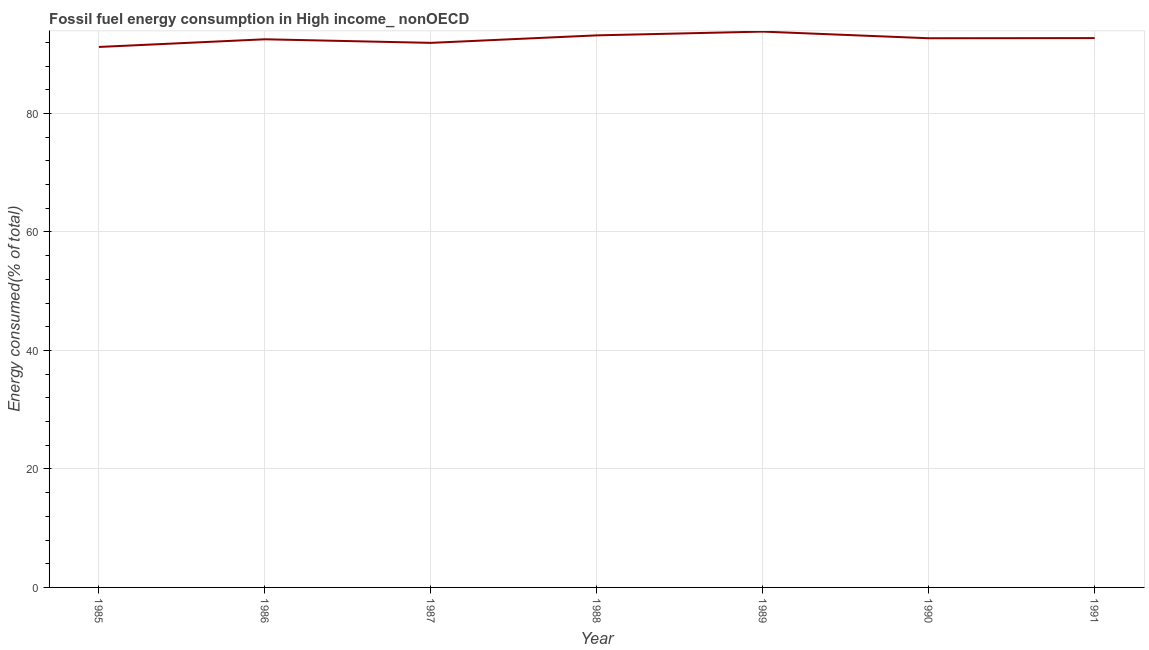What is the fossil fuel energy consumption in 1989?
Your response must be concise. 93.81. Across all years, what is the maximum fossil fuel energy consumption?
Give a very brief answer. 93.81. Across all years, what is the minimum fossil fuel energy consumption?
Your answer should be very brief. 91.21. In which year was the fossil fuel energy consumption maximum?
Your response must be concise. 1989. In which year was the fossil fuel energy consumption minimum?
Offer a very short reply. 1985. What is the sum of the fossil fuel energy consumption?
Your response must be concise. 648.01. What is the difference between the fossil fuel energy consumption in 1985 and 1987?
Your response must be concise. -0.69. What is the average fossil fuel energy consumption per year?
Keep it short and to the point. 92.57. What is the median fossil fuel energy consumption?
Your response must be concise. 92.68. In how many years, is the fossil fuel energy consumption greater than 80 %?
Keep it short and to the point. 7. Do a majority of the years between 1990 and 1988 (inclusive) have fossil fuel energy consumption greater than 24 %?
Your answer should be very brief. No. What is the ratio of the fossil fuel energy consumption in 1986 to that in 1989?
Ensure brevity in your answer.  0.99. What is the difference between the highest and the second highest fossil fuel energy consumption?
Offer a terse response. 0.64. Is the sum of the fossil fuel energy consumption in 1986 and 1990 greater than the maximum fossil fuel energy consumption across all years?
Your response must be concise. Yes. What is the difference between the highest and the lowest fossil fuel energy consumption?
Your answer should be very brief. 2.59. In how many years, is the fossil fuel energy consumption greater than the average fossil fuel energy consumption taken over all years?
Offer a terse response. 4. Does the fossil fuel energy consumption monotonically increase over the years?
Provide a succinct answer. No. How many lines are there?
Ensure brevity in your answer.  1. How many years are there in the graph?
Offer a terse response. 7. Are the values on the major ticks of Y-axis written in scientific E-notation?
Offer a terse response. No. Does the graph contain any zero values?
Offer a terse response. No. Does the graph contain grids?
Keep it short and to the point. Yes. What is the title of the graph?
Keep it short and to the point. Fossil fuel energy consumption in High income_ nonOECD. What is the label or title of the X-axis?
Keep it short and to the point. Year. What is the label or title of the Y-axis?
Give a very brief answer. Energy consumed(% of total). What is the Energy consumed(% of total) in 1985?
Keep it short and to the point. 91.21. What is the Energy consumed(% of total) of 1986?
Offer a very short reply. 92.51. What is the Energy consumed(% of total) of 1987?
Provide a succinct answer. 91.91. What is the Energy consumed(% of total) in 1988?
Your answer should be very brief. 93.17. What is the Energy consumed(% of total) of 1989?
Keep it short and to the point. 93.81. What is the Energy consumed(% of total) of 1990?
Give a very brief answer. 92.68. What is the Energy consumed(% of total) in 1991?
Ensure brevity in your answer.  92.71. What is the difference between the Energy consumed(% of total) in 1985 and 1986?
Offer a terse response. -1.29. What is the difference between the Energy consumed(% of total) in 1985 and 1987?
Your answer should be very brief. -0.69. What is the difference between the Energy consumed(% of total) in 1985 and 1988?
Keep it short and to the point. -1.96. What is the difference between the Energy consumed(% of total) in 1985 and 1989?
Make the answer very short. -2.59. What is the difference between the Energy consumed(% of total) in 1985 and 1990?
Make the answer very short. -1.47. What is the difference between the Energy consumed(% of total) in 1985 and 1991?
Keep it short and to the point. -1.5. What is the difference between the Energy consumed(% of total) in 1986 and 1987?
Offer a terse response. 0.6. What is the difference between the Energy consumed(% of total) in 1986 and 1988?
Offer a very short reply. -0.66. What is the difference between the Energy consumed(% of total) in 1986 and 1989?
Make the answer very short. -1.3. What is the difference between the Energy consumed(% of total) in 1986 and 1990?
Provide a short and direct response. -0.18. What is the difference between the Energy consumed(% of total) in 1986 and 1991?
Your answer should be compact. -0.2. What is the difference between the Energy consumed(% of total) in 1987 and 1988?
Offer a terse response. -1.27. What is the difference between the Energy consumed(% of total) in 1987 and 1989?
Provide a succinct answer. -1.9. What is the difference between the Energy consumed(% of total) in 1987 and 1990?
Your answer should be very brief. -0.78. What is the difference between the Energy consumed(% of total) in 1987 and 1991?
Ensure brevity in your answer.  -0.8. What is the difference between the Energy consumed(% of total) in 1988 and 1989?
Your answer should be compact. -0.64. What is the difference between the Energy consumed(% of total) in 1988 and 1990?
Your answer should be compact. 0.49. What is the difference between the Energy consumed(% of total) in 1988 and 1991?
Offer a very short reply. 0.46. What is the difference between the Energy consumed(% of total) in 1989 and 1990?
Keep it short and to the point. 1.12. What is the difference between the Energy consumed(% of total) in 1989 and 1991?
Provide a short and direct response. 1.1. What is the difference between the Energy consumed(% of total) in 1990 and 1991?
Provide a succinct answer. -0.03. What is the ratio of the Energy consumed(% of total) in 1985 to that in 1986?
Give a very brief answer. 0.99. What is the ratio of the Energy consumed(% of total) in 1985 to that in 1987?
Your answer should be very brief. 0.99. What is the ratio of the Energy consumed(% of total) in 1985 to that in 1988?
Make the answer very short. 0.98. What is the ratio of the Energy consumed(% of total) in 1985 to that in 1989?
Provide a succinct answer. 0.97. What is the ratio of the Energy consumed(% of total) in 1985 to that in 1990?
Give a very brief answer. 0.98. What is the ratio of the Energy consumed(% of total) in 1986 to that in 1988?
Ensure brevity in your answer.  0.99. What is the ratio of the Energy consumed(% of total) in 1986 to that in 1989?
Your answer should be compact. 0.99. What is the ratio of the Energy consumed(% of total) in 1986 to that in 1991?
Offer a very short reply. 1. What is the ratio of the Energy consumed(% of total) in 1987 to that in 1988?
Offer a very short reply. 0.99. What is the ratio of the Energy consumed(% of total) in 1987 to that in 1989?
Offer a terse response. 0.98. What is the ratio of the Energy consumed(% of total) in 1988 to that in 1989?
Your answer should be compact. 0.99. What is the ratio of the Energy consumed(% of total) in 1989 to that in 1990?
Provide a succinct answer. 1.01. What is the ratio of the Energy consumed(% of total) in 1989 to that in 1991?
Offer a terse response. 1.01. What is the ratio of the Energy consumed(% of total) in 1990 to that in 1991?
Give a very brief answer. 1. 